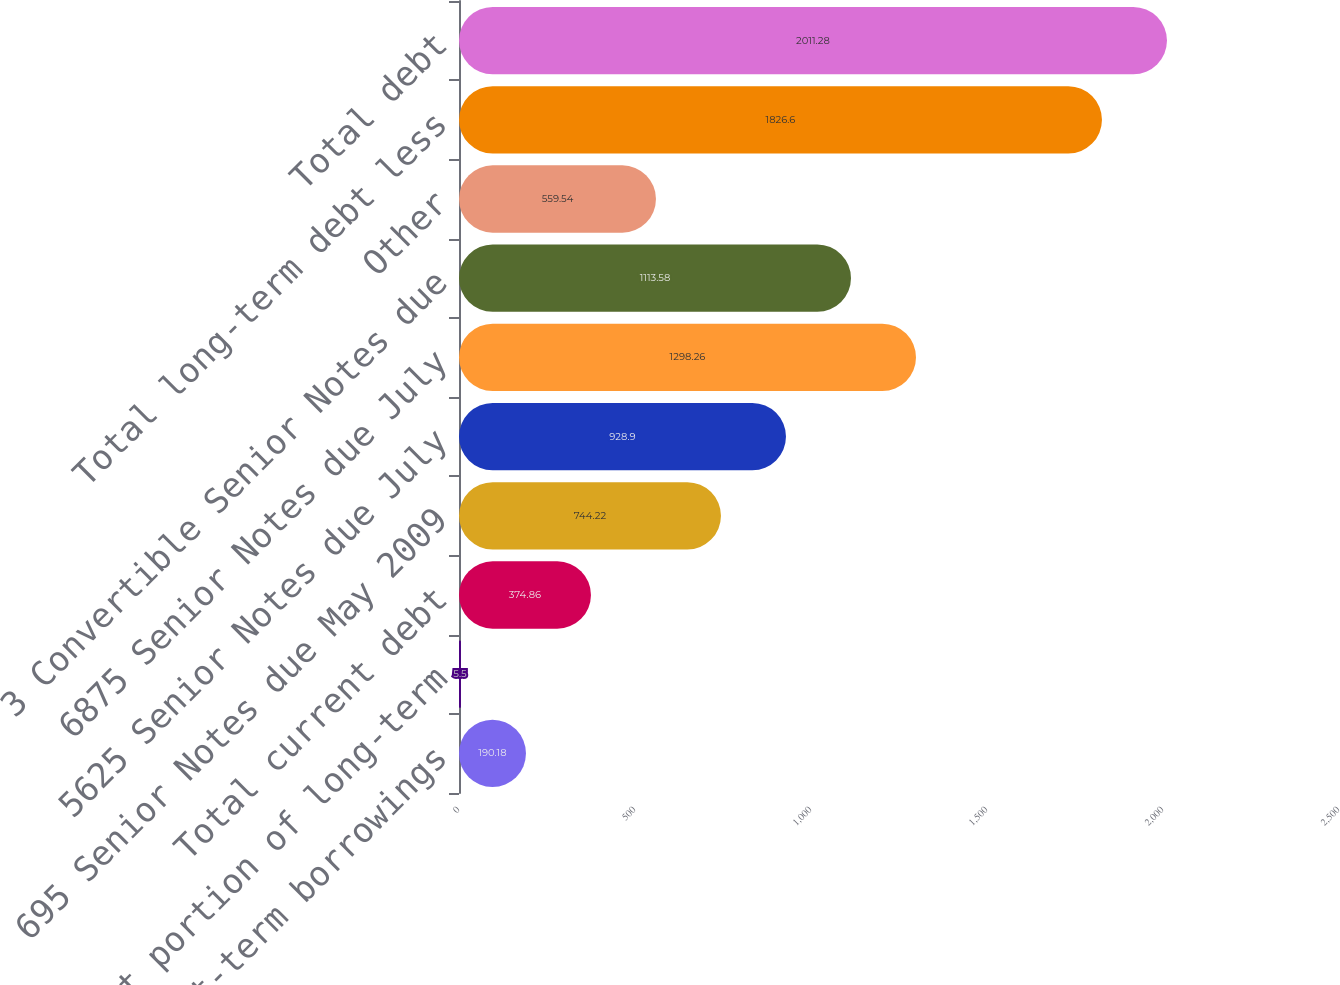Convert chart. <chart><loc_0><loc_0><loc_500><loc_500><bar_chart><fcel>Short-term borrowings<fcel>Current portion of long-term<fcel>Total current debt<fcel>695 Senior Notes due May 2009<fcel>5625 Senior Notes due July<fcel>6875 Senior Notes due July<fcel>3 Convertible Senior Notes due<fcel>Other<fcel>Total long-term debt less<fcel>Total debt<nl><fcel>190.18<fcel>5.5<fcel>374.86<fcel>744.22<fcel>928.9<fcel>1298.26<fcel>1113.58<fcel>559.54<fcel>1826.6<fcel>2011.28<nl></chart> 